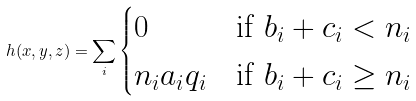Convert formula to latex. <formula><loc_0><loc_0><loc_500><loc_500>h ( x , y , z ) = \sum _ { i } \begin{cases} 0 & \text {if } b _ { i } + c _ { i } < n _ { i } \\ n _ { i } a _ { i } q _ { i } & \text {if } b _ { i } + c _ { i } \geq n _ { i } \end{cases}</formula> 